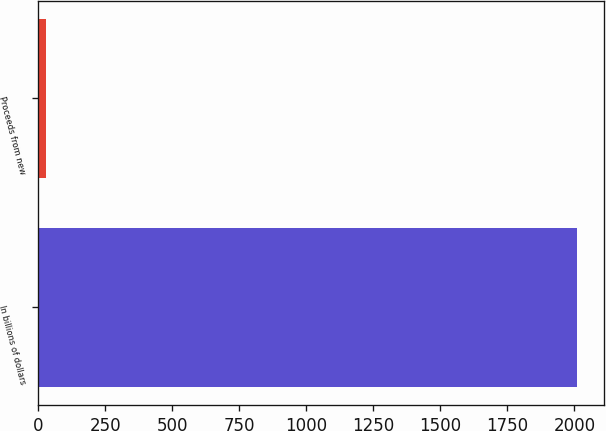Convert chart. <chart><loc_0><loc_0><loc_500><loc_500><bar_chart><fcel>In billions of dollars<fcel>Proceeds from new<nl><fcel>2009<fcel>29.4<nl></chart> 